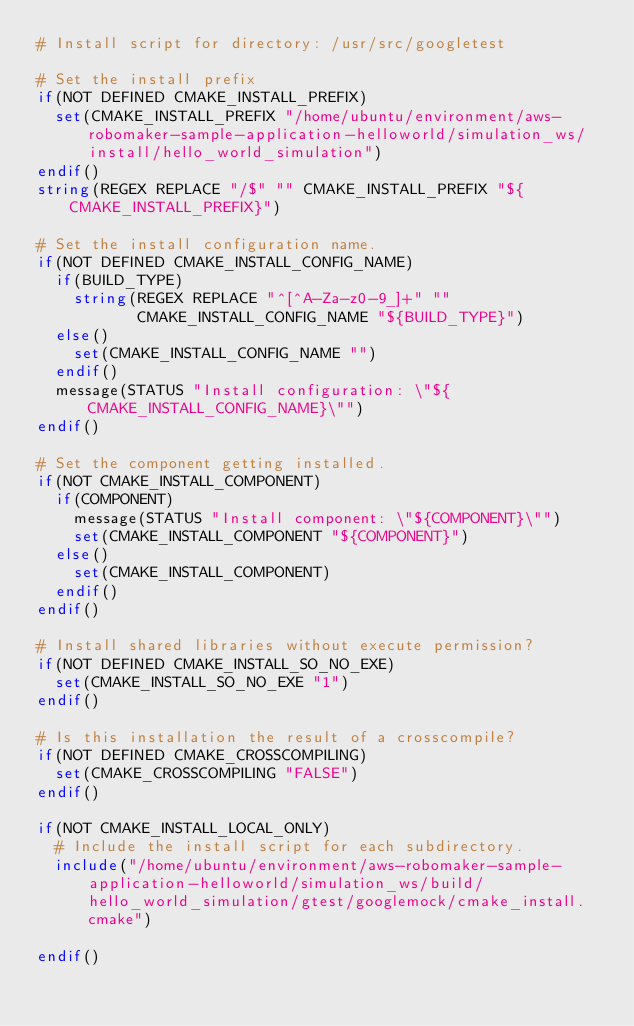Convert code to text. <code><loc_0><loc_0><loc_500><loc_500><_CMake_># Install script for directory: /usr/src/googletest

# Set the install prefix
if(NOT DEFINED CMAKE_INSTALL_PREFIX)
  set(CMAKE_INSTALL_PREFIX "/home/ubuntu/environment/aws-robomaker-sample-application-helloworld/simulation_ws/install/hello_world_simulation")
endif()
string(REGEX REPLACE "/$" "" CMAKE_INSTALL_PREFIX "${CMAKE_INSTALL_PREFIX}")

# Set the install configuration name.
if(NOT DEFINED CMAKE_INSTALL_CONFIG_NAME)
  if(BUILD_TYPE)
    string(REGEX REPLACE "^[^A-Za-z0-9_]+" ""
           CMAKE_INSTALL_CONFIG_NAME "${BUILD_TYPE}")
  else()
    set(CMAKE_INSTALL_CONFIG_NAME "")
  endif()
  message(STATUS "Install configuration: \"${CMAKE_INSTALL_CONFIG_NAME}\"")
endif()

# Set the component getting installed.
if(NOT CMAKE_INSTALL_COMPONENT)
  if(COMPONENT)
    message(STATUS "Install component: \"${COMPONENT}\"")
    set(CMAKE_INSTALL_COMPONENT "${COMPONENT}")
  else()
    set(CMAKE_INSTALL_COMPONENT)
  endif()
endif()

# Install shared libraries without execute permission?
if(NOT DEFINED CMAKE_INSTALL_SO_NO_EXE)
  set(CMAKE_INSTALL_SO_NO_EXE "1")
endif()

# Is this installation the result of a crosscompile?
if(NOT DEFINED CMAKE_CROSSCOMPILING)
  set(CMAKE_CROSSCOMPILING "FALSE")
endif()

if(NOT CMAKE_INSTALL_LOCAL_ONLY)
  # Include the install script for each subdirectory.
  include("/home/ubuntu/environment/aws-robomaker-sample-application-helloworld/simulation_ws/build/hello_world_simulation/gtest/googlemock/cmake_install.cmake")

endif()

</code> 